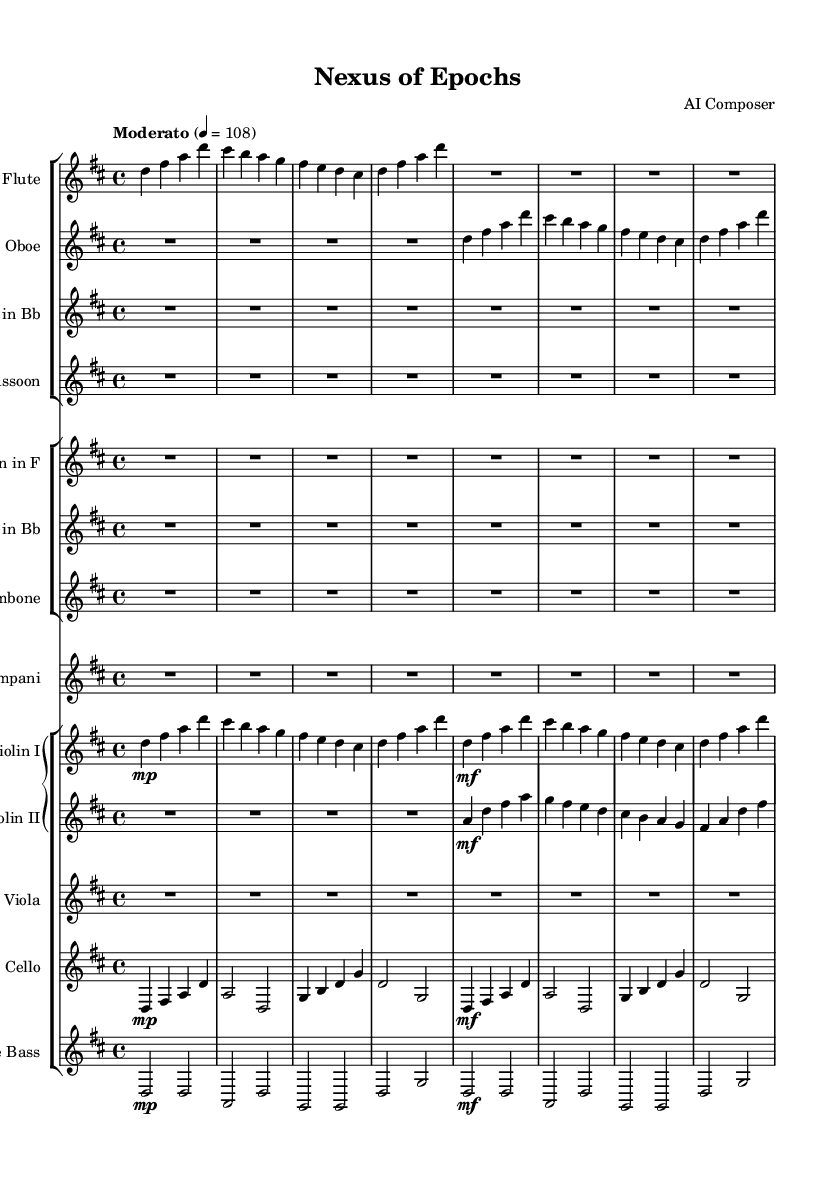What is the key signature of this music? The key signature is indicated at the beginning of the staff and shows two sharps. This corresponds to the key of D major, which contains the notes D, E, F#, G, A, B, and C#.
Answer: D major What is the time signature of this piece? The time signature is found at the start of the score, indicated as 4/4, meaning that there are four beats in each measure and the quarter note receives one beat.
Answer: 4/4 What is the tempo marking of the symphony? The tempo marking is typically given at the beginning of the score, stating "Moderato" with a metronome mark of 108. This indicates a moderate speed of play.
Answer: Moderato How many instruments are in the woodwind section? The woodwind section consists of four instruments: flute, oboe, clarinet, and bassoon, as identified in their respective staves at the start of the score.
Answer: Four Which section utilizes the double bass? In the score, the double bass is listed in the string section, specifically indicated in its own staff, providing bass lines for orchestral harmony.
Answer: String section What is the dynamic marking for Violin I in the first measure? The dynamic marking for Violin I in the first measure shows "mp," which stands for "mezzo-piano," indicating a moderately soft volume.
Answer: mp How many measures does the flute part contain before a rest? The flute part contains four measures of music before ending on a whole rest, as shown by the 'R1*4' in the last section of the flute line.
Answer: Four 